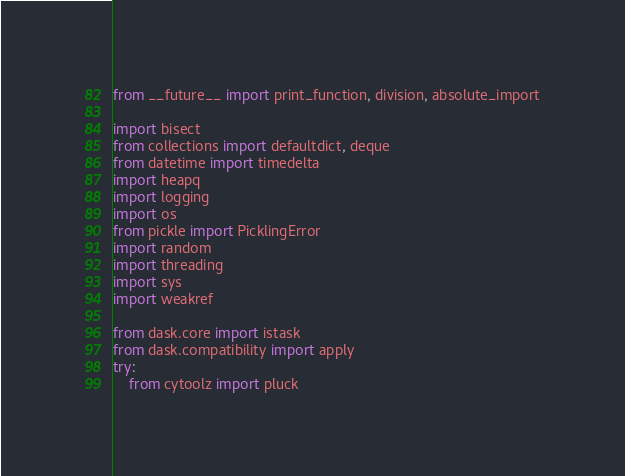<code> <loc_0><loc_0><loc_500><loc_500><_Python_>from __future__ import print_function, division, absolute_import

import bisect
from collections import defaultdict, deque
from datetime import timedelta
import heapq
import logging
import os
from pickle import PicklingError
import random
import threading
import sys
import weakref

from dask.core import istask
from dask.compatibility import apply
try:
    from cytoolz import pluck</code> 